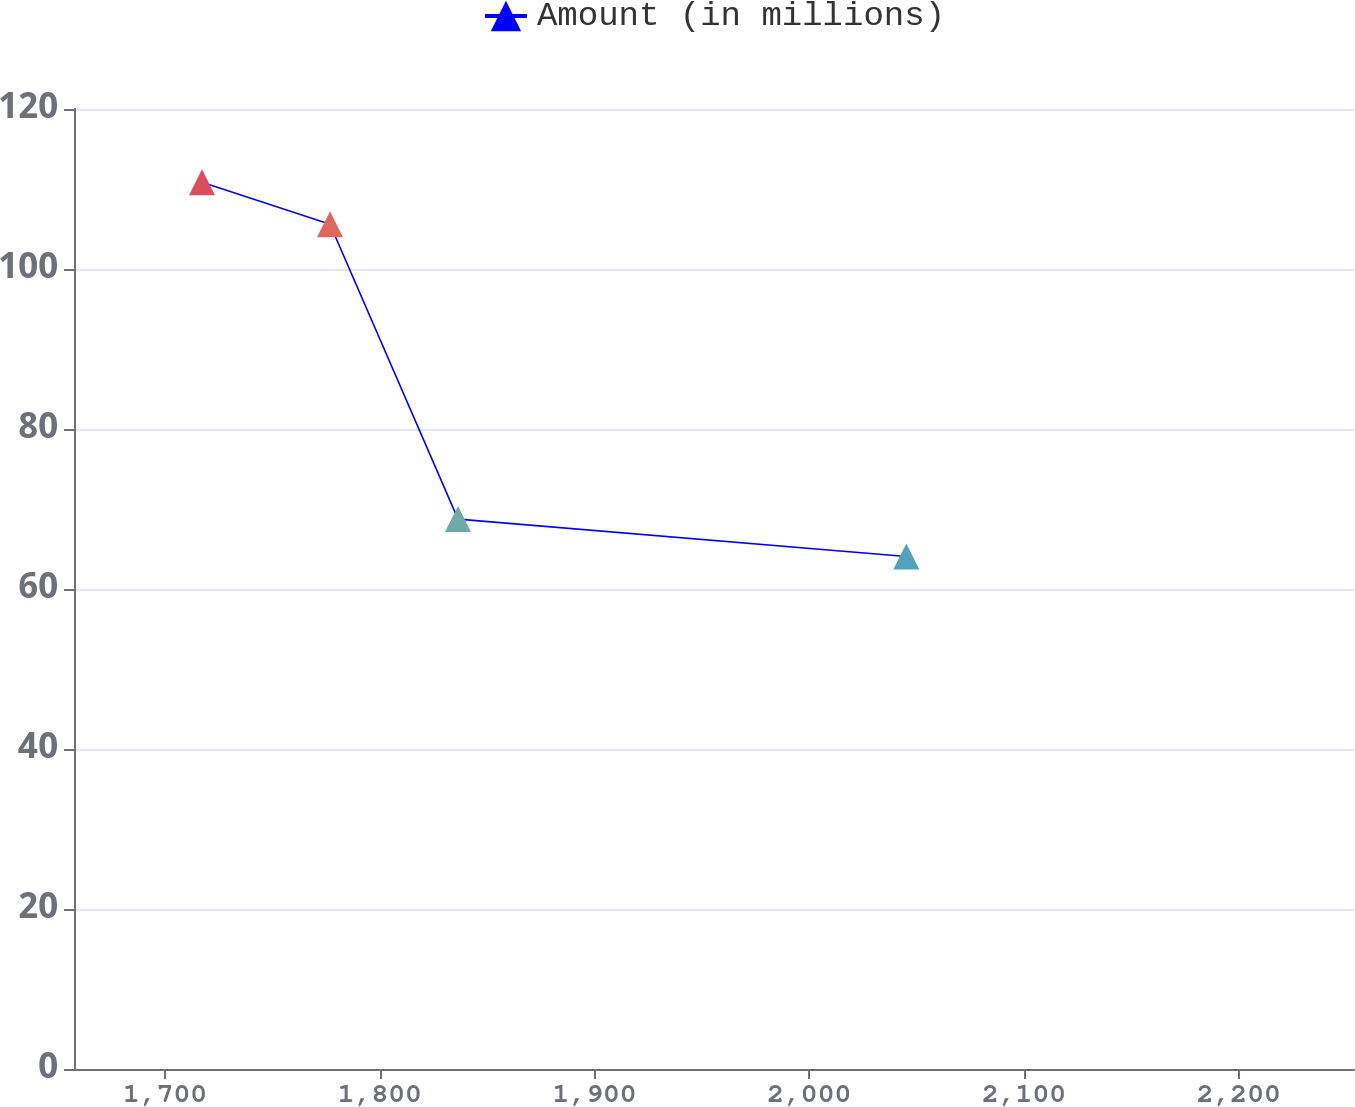Convert chart. <chart><loc_0><loc_0><loc_500><loc_500><line_chart><ecel><fcel>Amount (in millions)<nl><fcel>1717.21<fcel>110.84<nl><fcel>1776.82<fcel>105.59<nl><fcel>1836.43<fcel>68.74<nl><fcel>2045.18<fcel>64.06<nl><fcel>2313.27<fcel>73.42<nl></chart> 